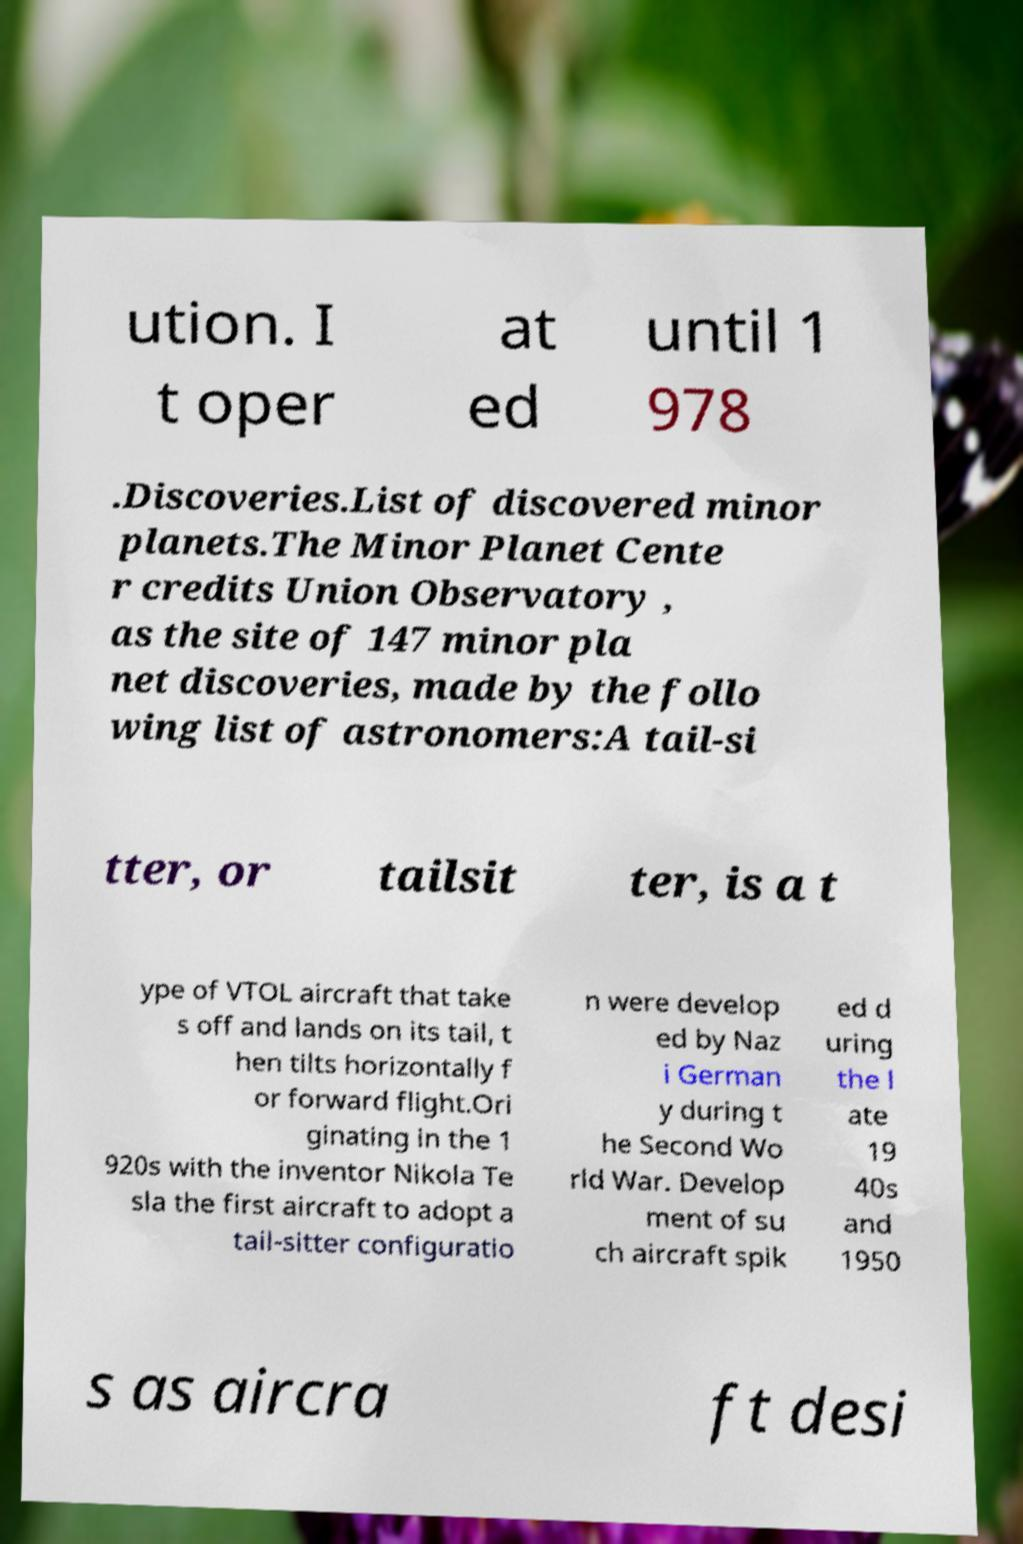Please identify and transcribe the text found in this image. ution. I t oper at ed until 1 978 .Discoveries.List of discovered minor planets.The Minor Planet Cente r credits Union Observatory , as the site of 147 minor pla net discoveries, made by the follo wing list of astronomers:A tail-si tter, or tailsit ter, is a t ype of VTOL aircraft that take s off and lands on its tail, t hen tilts horizontally f or forward flight.Ori ginating in the 1 920s with the inventor Nikola Te sla the first aircraft to adopt a tail-sitter configuratio n were develop ed by Naz i German y during t he Second Wo rld War. Develop ment of su ch aircraft spik ed d uring the l ate 19 40s and 1950 s as aircra ft desi 